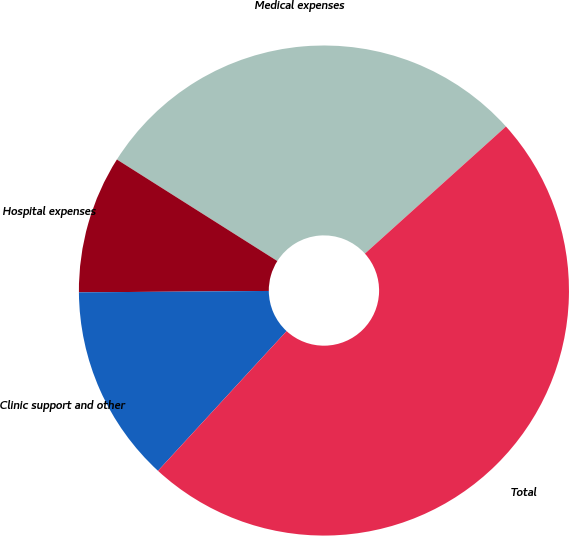Convert chart. <chart><loc_0><loc_0><loc_500><loc_500><pie_chart><fcel>Medical expenses<fcel>Hospital expenses<fcel>Clinic support and other<fcel>Total<nl><fcel>29.35%<fcel>9.1%<fcel>13.04%<fcel>48.52%<nl></chart> 